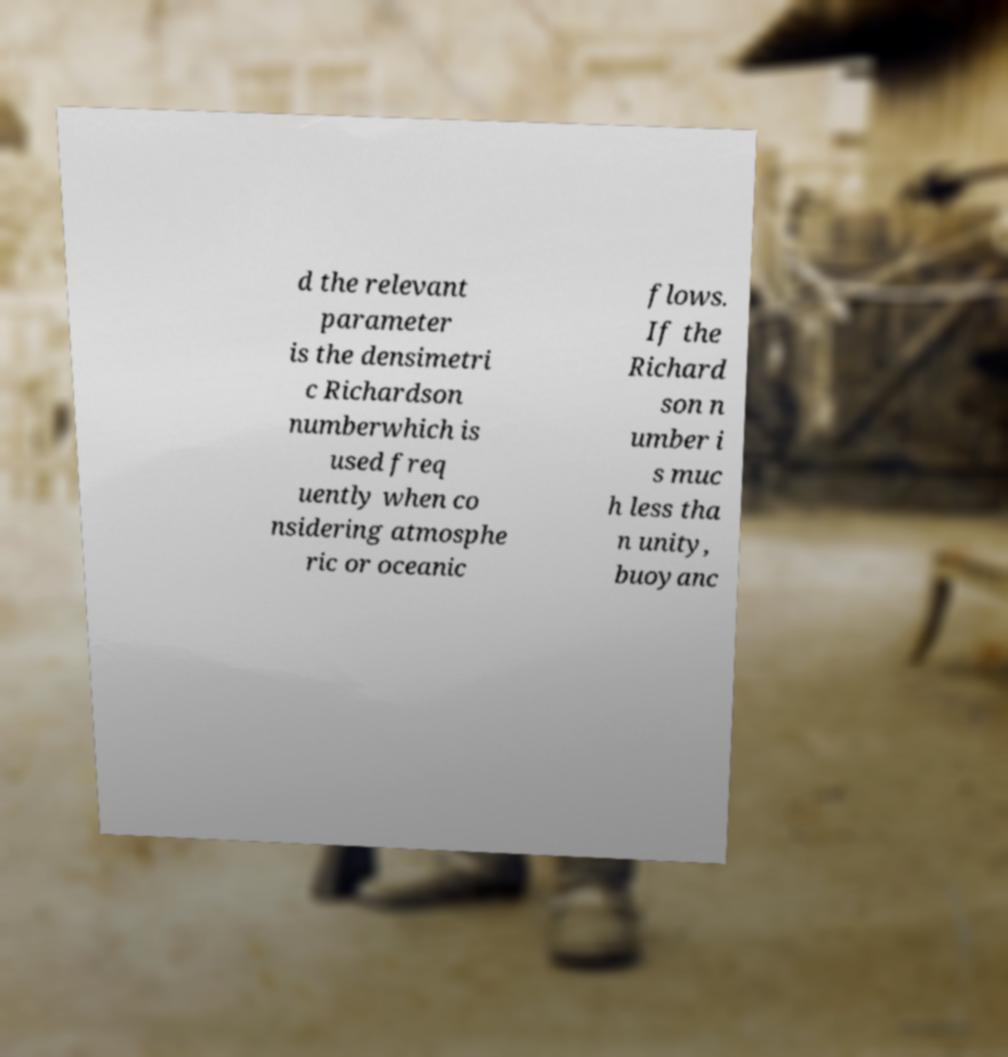I need the written content from this picture converted into text. Can you do that? d the relevant parameter is the densimetri c Richardson numberwhich is used freq uently when co nsidering atmosphe ric or oceanic flows. If the Richard son n umber i s muc h less tha n unity, buoyanc 